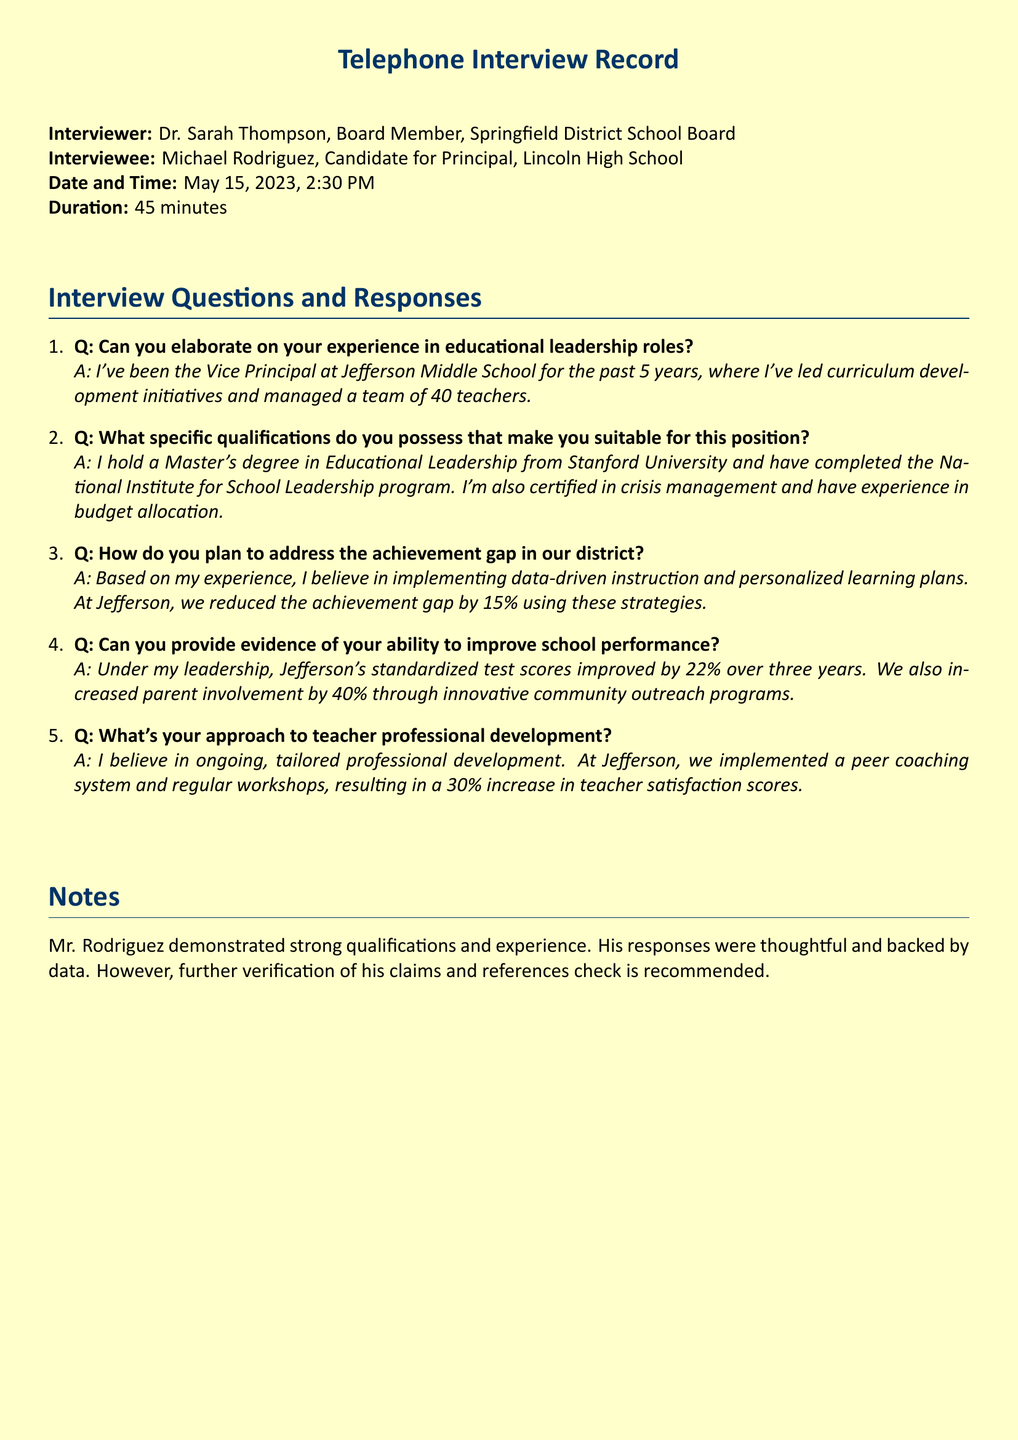What is the date of the interview? The date of the interview is specifically mentioned in the document as May 15, 2023.
Answer: May 15, 2023 Who is the interviewer? The interviewer is identified in the document as Dr. Sarah Thompson, a Board Member.
Answer: Dr. Sarah Thompson How long did the interview last? The duration of the interview is specified in the document as 45 minutes.
Answer: 45 minutes What position is Michael Rodriguez applying for? Michael Rodriguez's desired position is stated in the document as Principal of Lincoln High School.
Answer: Principal What degree does Michael Rodriguez hold? The document indicates that he holds a Master's degree in Educational Leadership.
Answer: Master's degree in Educational Leadership What improvement in standardized test scores did Jefferson achieve? The document reports that Jefferson's standardized test scores improved by 22% over three years.
Answer: 22% What professional development system did Michael Rodriguez implement? He implemented a peer coaching system for professional development, which is mentioned in the document.
Answer: Peer coaching system What was the percentage increase in parent involvement? The document states that parent involvement increased by 40% under his leadership.
Answer: 40% What specific training program did he complete? The document indicates that he completed the National Institute for School Leadership program.
Answer: National Institute for School Leadership program 